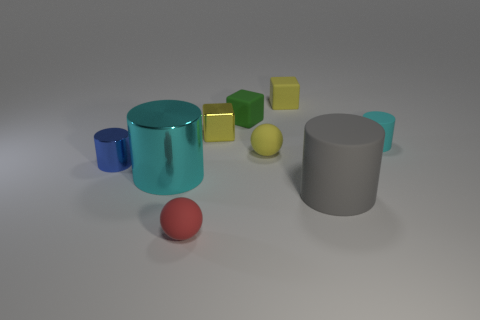Subtract all blue metallic cylinders. How many cylinders are left? 3 Subtract all blue cylinders. How many cylinders are left? 3 Subtract all purple cylinders. Subtract all purple blocks. How many cylinders are left? 4 Subtract all cylinders. How many objects are left? 5 Add 3 tiny yellow rubber blocks. How many tiny yellow rubber blocks exist? 4 Subtract 0 cyan balls. How many objects are left? 9 Subtract all small objects. Subtract all small blue shiny cylinders. How many objects are left? 1 Add 9 small yellow shiny objects. How many small yellow shiny objects are left? 10 